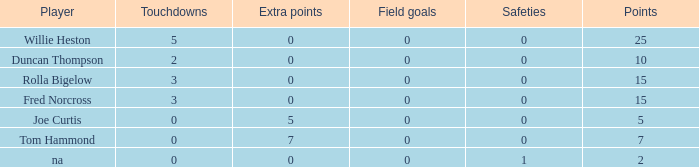Parse the full table. {'header': ['Player', 'Touchdowns', 'Extra points', 'Field goals', 'Safeties', 'Points'], 'rows': [['Willie Heston', '5', '0', '0', '0', '25'], ['Duncan Thompson', '2', '0', '0', '0', '10'], ['Rolla Bigelow', '3', '0', '0', '0', '15'], ['Fred Norcross', '3', '0', '0', '0', '15'], ['Joe Curtis', '0', '5', '0', '0', '5'], ['Tom Hammond', '0', '7', '0', '0', '7'], ['na', '0', '0', '0', '1', '2']]} How many Touchdowns have a Player of rolla bigelow, and an Extra points smaller than 0? None. 